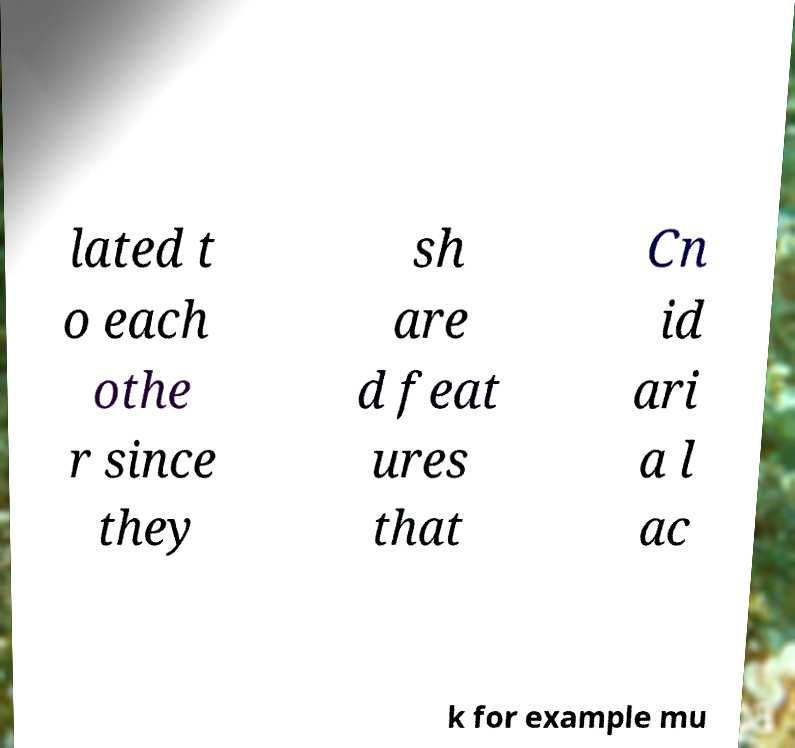There's text embedded in this image that I need extracted. Can you transcribe it verbatim? lated t o each othe r since they sh are d feat ures that Cn id ari a l ac k for example mu 